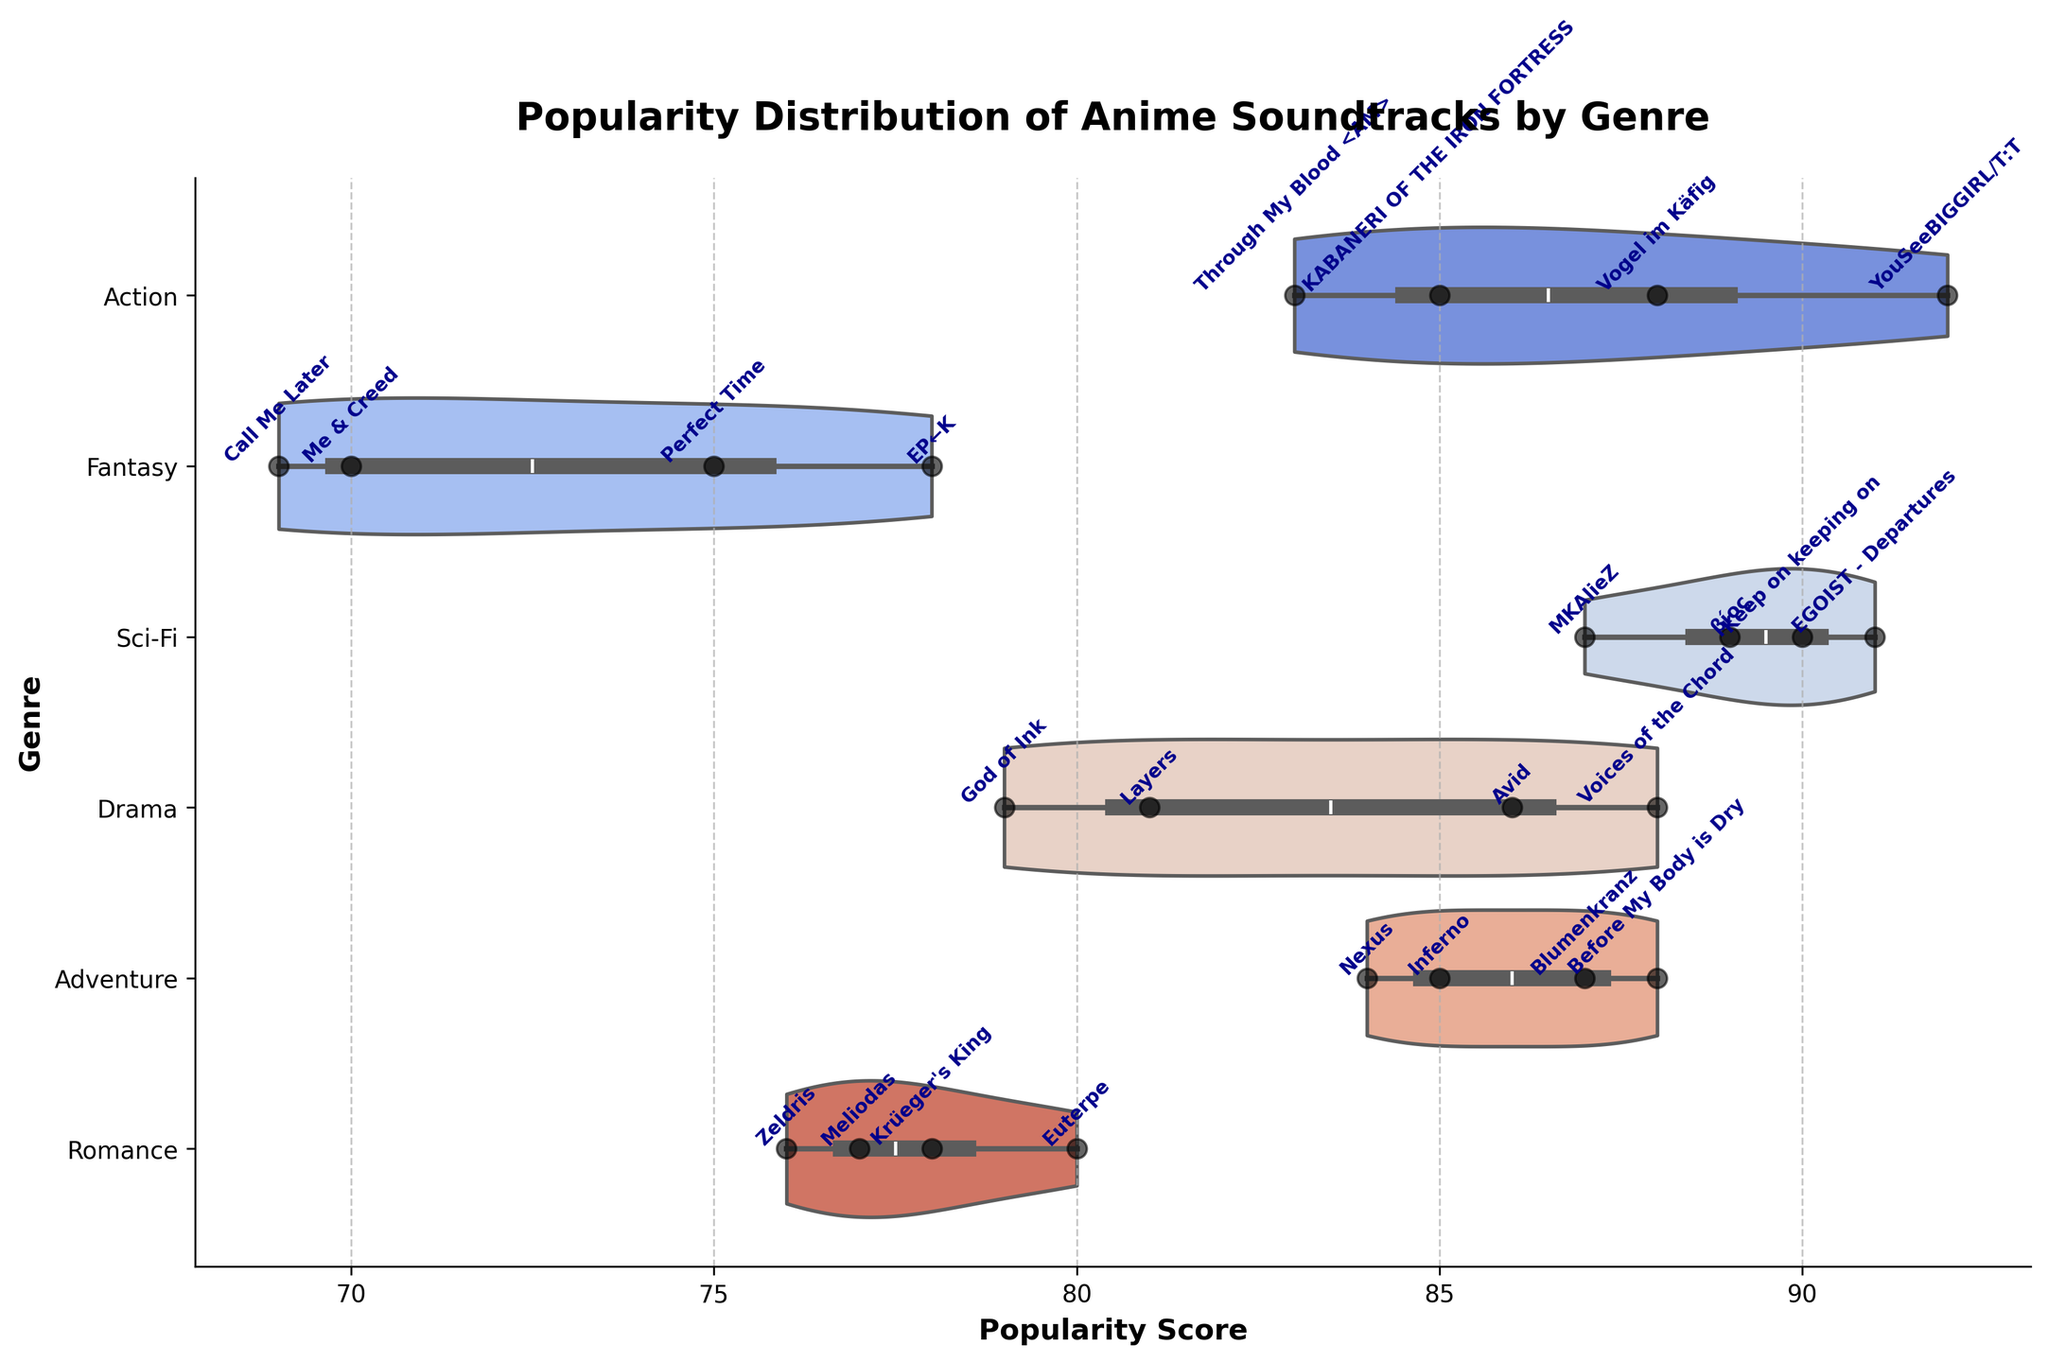what is the title of the chart? The title is located at the top center of the chart and it summarizes the content of the visualization. In this case, it reads, "Popularity Distribution of Anime Soundtracks by Genre."
Answer: Popularity Distribution of Anime Soundtracks by Genre which genre has the soundtrack with the highest popularity score? By examining the farthest data point to the right on the x-axis, we see that the highest popularity score clusters appear in the Action genre. Specifically, the soundtrack "YouSeeBIGGIRL/T:T" from "Attack on Titan" has the highest score.
Answer: Action what is the median popularity score for the Sci-Fi genre's soundtracks? The violin plot has a distribution representing the popularity scores. The median is indicated by a central mark inside the thick portion of the plot. For the Sci-Fi genre, the median appears to be around 90.
Answer: 90 which genres show the widest spread of popularity scores? The horizontal width of the violin plots indicates the spread. The genres with the widest violins have greater variability in their scores. Both the Fantasy and Sci-Fi genres exhibit a notably wide spread.
Answer: Fantasy and Sci-Fi how does the popularity range of Adventure soundtracks compare to that of Drama soundtracks? The spread of popularity scores for Adventure soundtracks is between 84 and 88, while for Drama it's between 79 and 88. Therefore, the Adventure genre has a narrower range compared to the Drama genre.
Answer: Adventure has a narrower range how many soundtracks are there in the Romance genre and what is their popularity range? To determine the count, we can visually inspect the number of distinct dots over the horizontal axis for the Romance genre. There are 4 soundtracks ranging in popularity from 76 to 80.
Answer: 4 soundtracks ranging from 76 to 80 which genre contains the soundtrack "Avid," and what is its popularity score? By locating the text labels overlaid on the violin plots, we can identify which genre contains "Avid." It is found in the Drama genre with a popularity score of 86.
Answer: Drama, 86 what is the average popularity score of the soundtracks in the Action genre? The popularity scores for Action soundtracks are 88, 92, 85, and 83. To calculate the average: (88 + 92 + 85 + 83) / 4 = 87.
Answer: 87 which genre shows the least variation in popularity scores? This can be determined by finding the genre with the narrowest violin plot, as it indicates less variation. Romance shows the least variation, with scores tightly clustered between 76 and 80.
Answer: Romance 